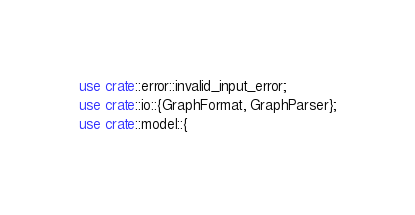<code> <loc_0><loc_0><loc_500><loc_500><_Rust_>use crate::error::invalid_input_error;
use crate::io::{GraphFormat, GraphParser};
use crate::model::{</code> 